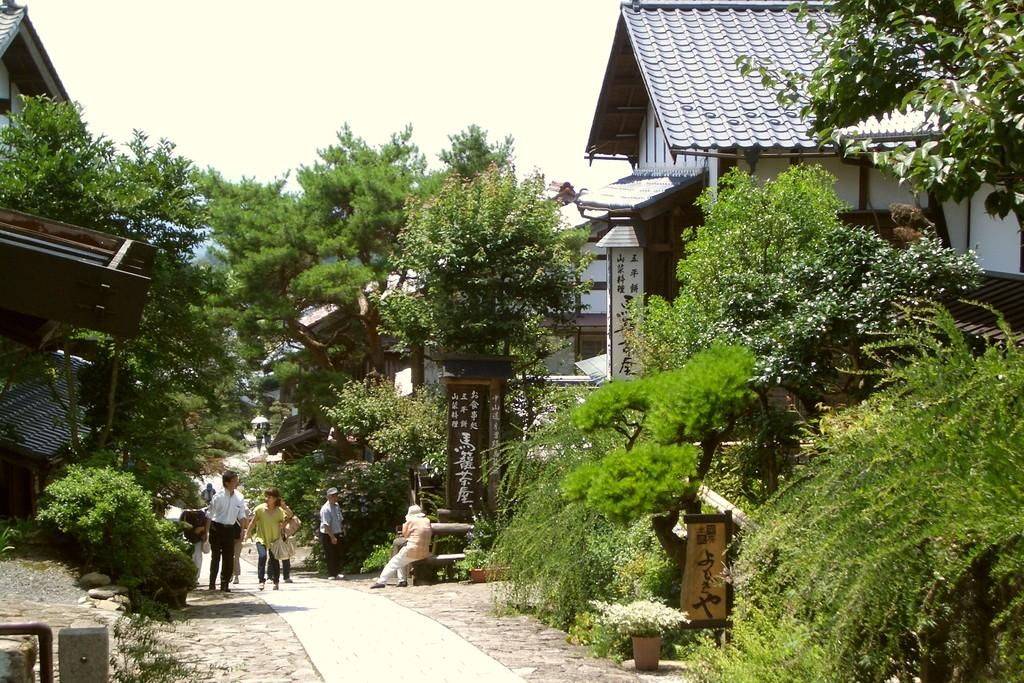What type of natural elements can be seen in the image? There are trees in the image. What type of man-made structures are present? There are buildings in the image. What are the people in the image doing? There are people walking in the image. Can you describe the woman's position in the image? The woman is seated in the image. How would you describe the weather based on the image? The sky is cloudy in the image. What type of signage or information is present in the image? There is a board with text in the image. Are there any plants visible in the image? Yes, there are plants in pots in the image. What type of fear can be seen on the faces of the people in the image? There is no indication of fear on the faces of the people in the image. What type of patch is sewn onto the woman's clothing in the image? There is no patch visible on the woman's clothing in the image. 